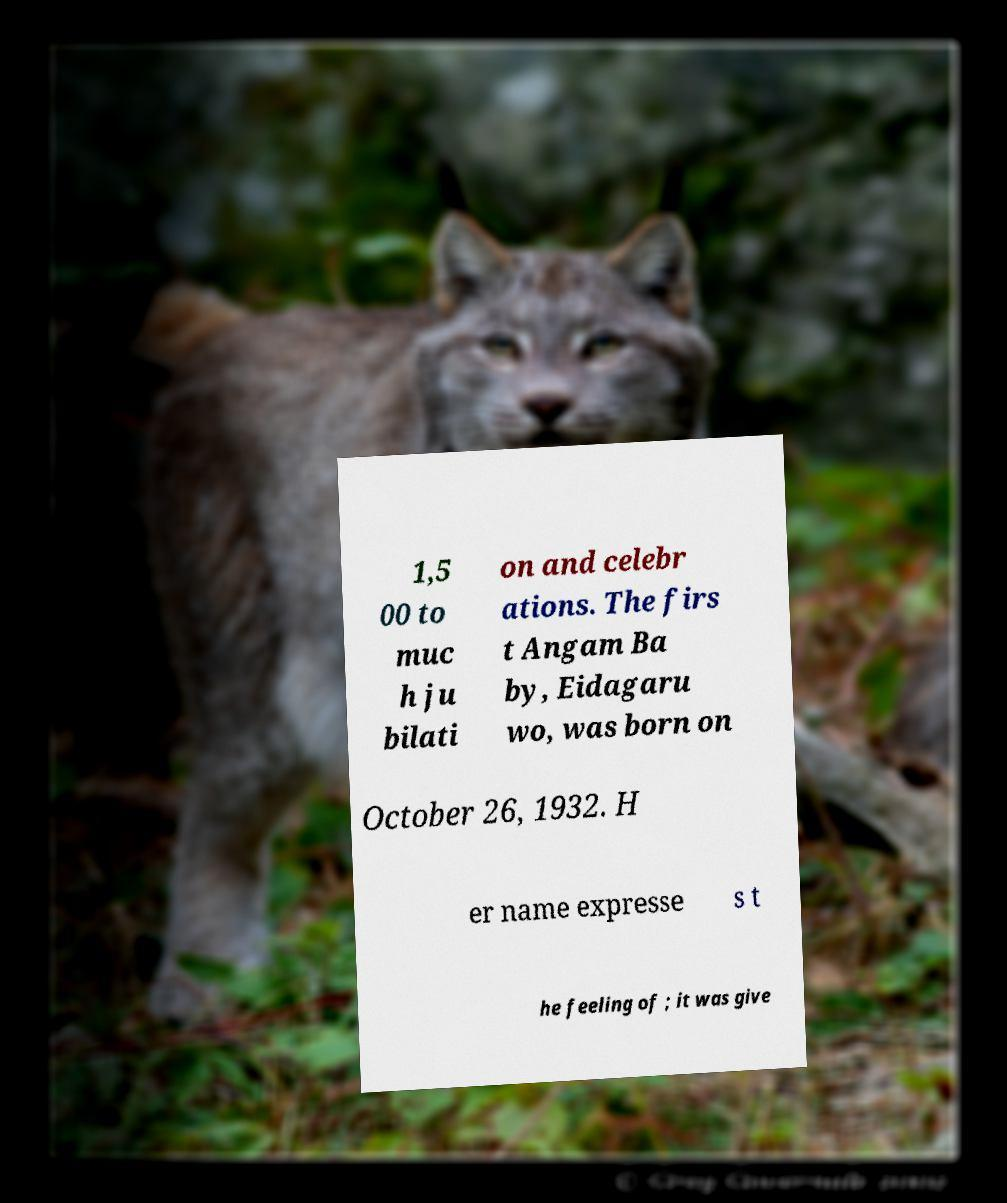For documentation purposes, I need the text within this image transcribed. Could you provide that? 1,5 00 to muc h ju bilati on and celebr ations. The firs t Angam Ba by, Eidagaru wo, was born on October 26, 1932. H er name expresse s t he feeling of ; it was give 